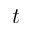Convert formula to latex. <formula><loc_0><loc_0><loc_500><loc_500>t</formula> 